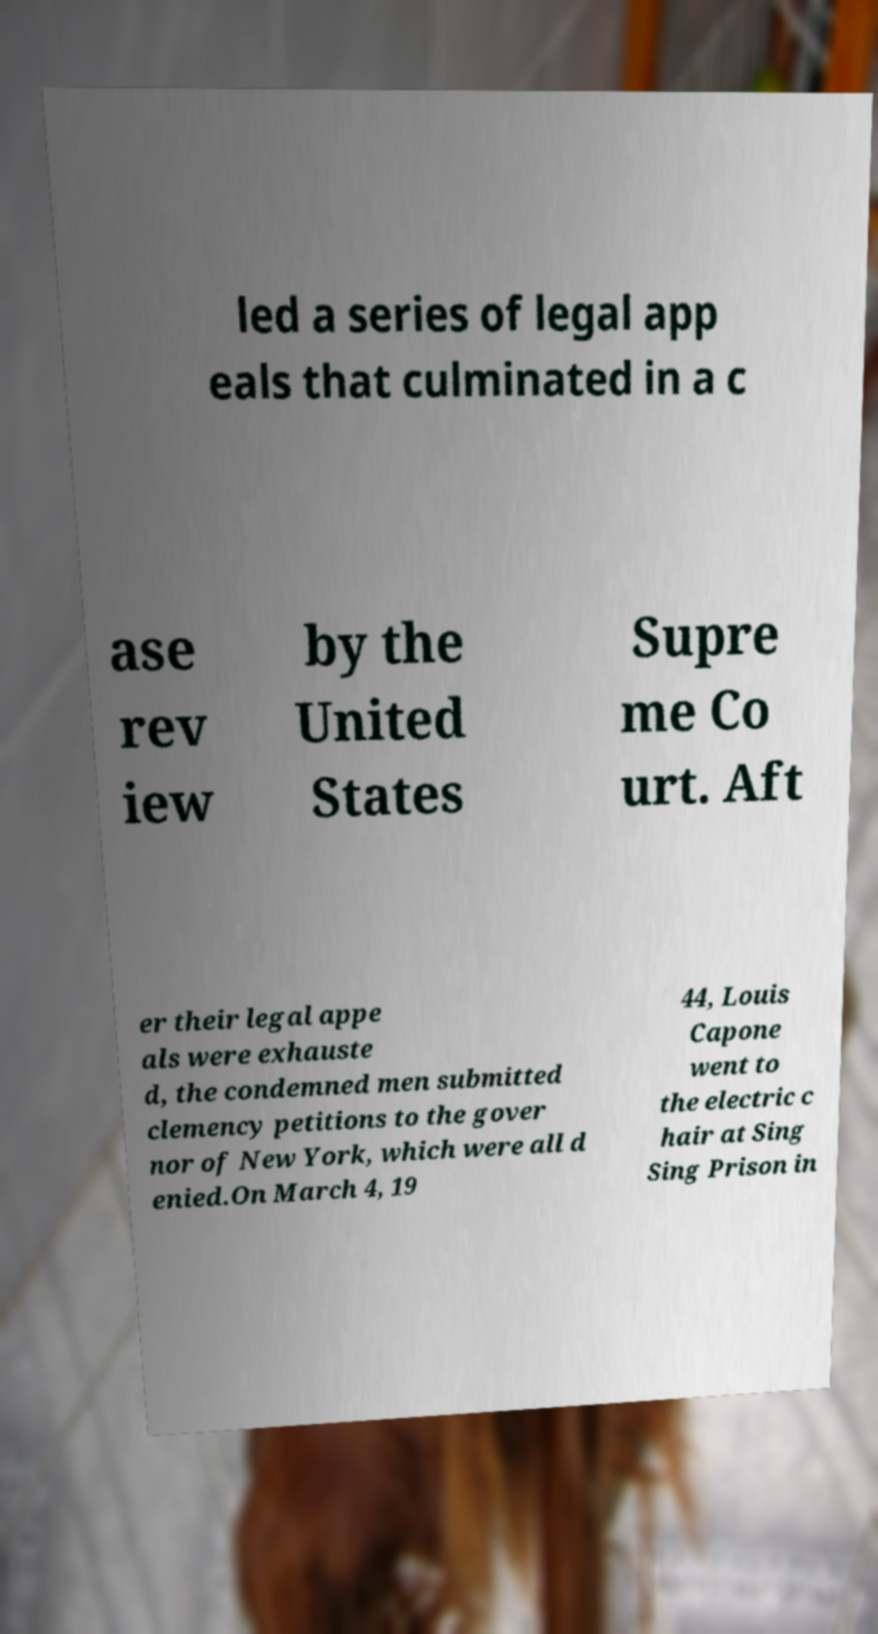Could you assist in decoding the text presented in this image and type it out clearly? led a series of legal app eals that culminated in a c ase rev iew by the United States Supre me Co urt. Aft er their legal appe als were exhauste d, the condemned men submitted clemency petitions to the gover nor of New York, which were all d enied.On March 4, 19 44, Louis Capone went to the electric c hair at Sing Sing Prison in 